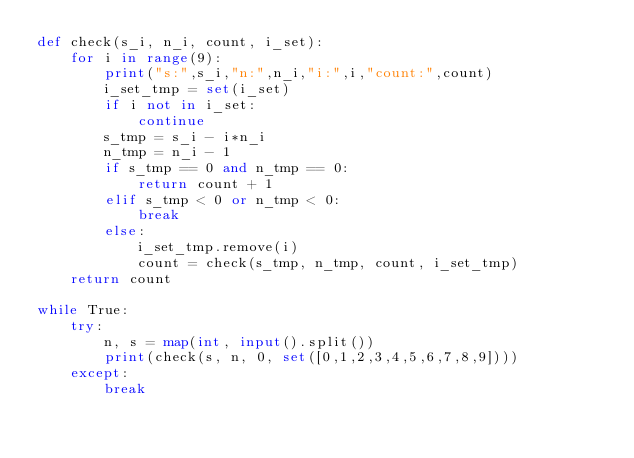<code> <loc_0><loc_0><loc_500><loc_500><_Python_>def check(s_i, n_i, count, i_set):
    for i in range(9):
        print("s:",s_i,"n:",n_i,"i:",i,"count:",count)
        i_set_tmp = set(i_set)
        if i not in i_set:
            continue
        s_tmp = s_i - i*n_i
        n_tmp = n_i - 1
        if s_tmp == 0 and n_tmp == 0:
            return count + 1
        elif s_tmp < 0 or n_tmp < 0:
            break
        else:
            i_set_tmp.remove(i)
            count = check(s_tmp, n_tmp, count, i_set_tmp)
    return count

while True:
    try:
        n, s = map(int, input().split())
        print(check(s, n, 0, set([0,1,2,3,4,5,6,7,8,9])))
    except:
        break

</code> 